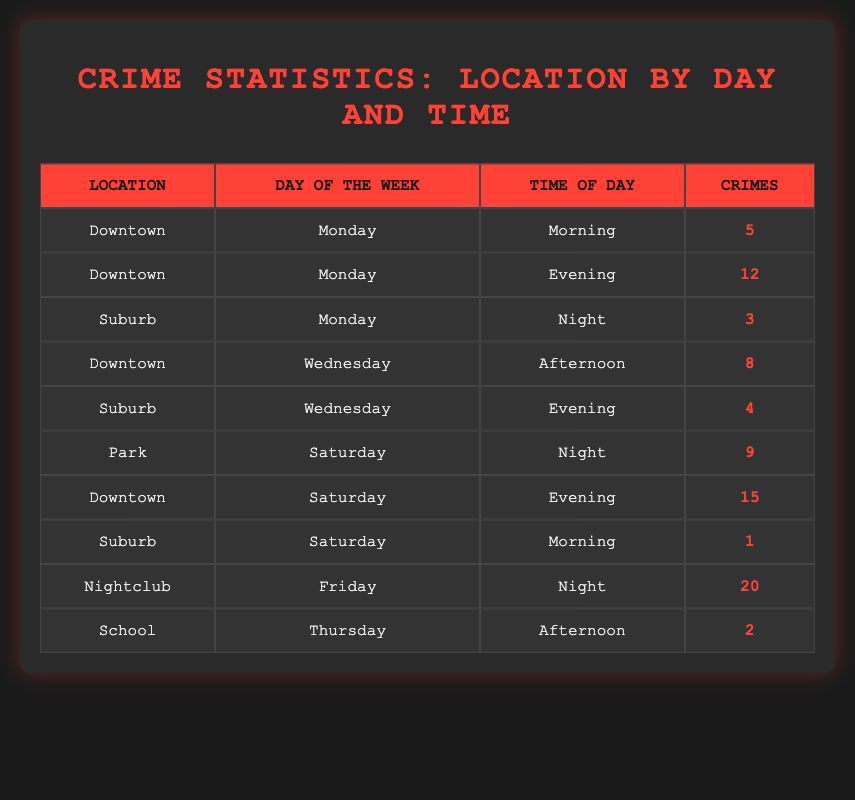What location had the highest number of crimes on a Friday? From the table, we see that the Nightclub has 20 crimes listed for Friday night, which is higher than any other locations and days.
Answer: Nightclub How many crimes occurred in Downtown on Monday? The table lists two entries for Downtown on Monday: 5 crimes in the morning and 12 crimes in the evening. Adding these gives a total of 5 + 12 = 17 crimes.
Answer: 17 Which day of the week had the least amount of crime in the Suburb? The table shows that on Monday there were 3 crimes and on Saturday just 1 crime. Since 1 is less than 3, Saturday is the day with the least crime for the Suburb.
Answer: Saturday Is there more crime in Downtown at night compared to the Park on Saturday? The table does not contain any data for Downtown at night. However, it shows 15 crimes in Downtown on Saturday evening and 9 crimes in the Park on Saturday night, therefore there is more crime in Downtown on Saturday evening than in the Park.
Answer: Yes What was the total number of crimes across all locations on Saturday? On Saturday, the crimes were 15 in Downtown (evening), 9 in Park (night), and 1 in Suburb (morning). Summing these values gives 15 + 9 + 1 = 25 crimes.
Answer: 25 What is the average number of crimes for each day mentioned in the table? The table lists crimes for the following days: Monday (17), Wednesday (12), Thursday (2), Friday (20), and Saturday (25). Adding these gives 17 + 12 + 2 + 20 + 25 = 76 total crimes over 5 days, which averages out to 76/5 = 15.2 crimes per day.
Answer: 15.2 Which location had the lowest number of crimes on any day? The table shows that on Saturday morning in the Suburb, there was only 1 crime, which is the only instance of 1 crime in the entire table.
Answer: Suburb Did any location report crimes during every time slot listed? In the table, Downtown is shown with crimes in morning and evening on Monday, afternoon on Wednesday, and evening on Saturday. As it does not cover all time slots (night not included), thus it did not report crimes in every time slot.
Answer: No 